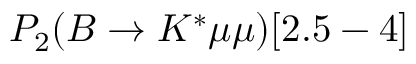<formula> <loc_0><loc_0><loc_500><loc_500>P _ { 2 } ( B \to K ^ { * } \mu \mu ) [ 2 . 5 - 4 ]</formula> 